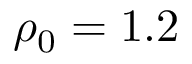<formula> <loc_0><loc_0><loc_500><loc_500>\rho _ { 0 } = 1 . 2</formula> 